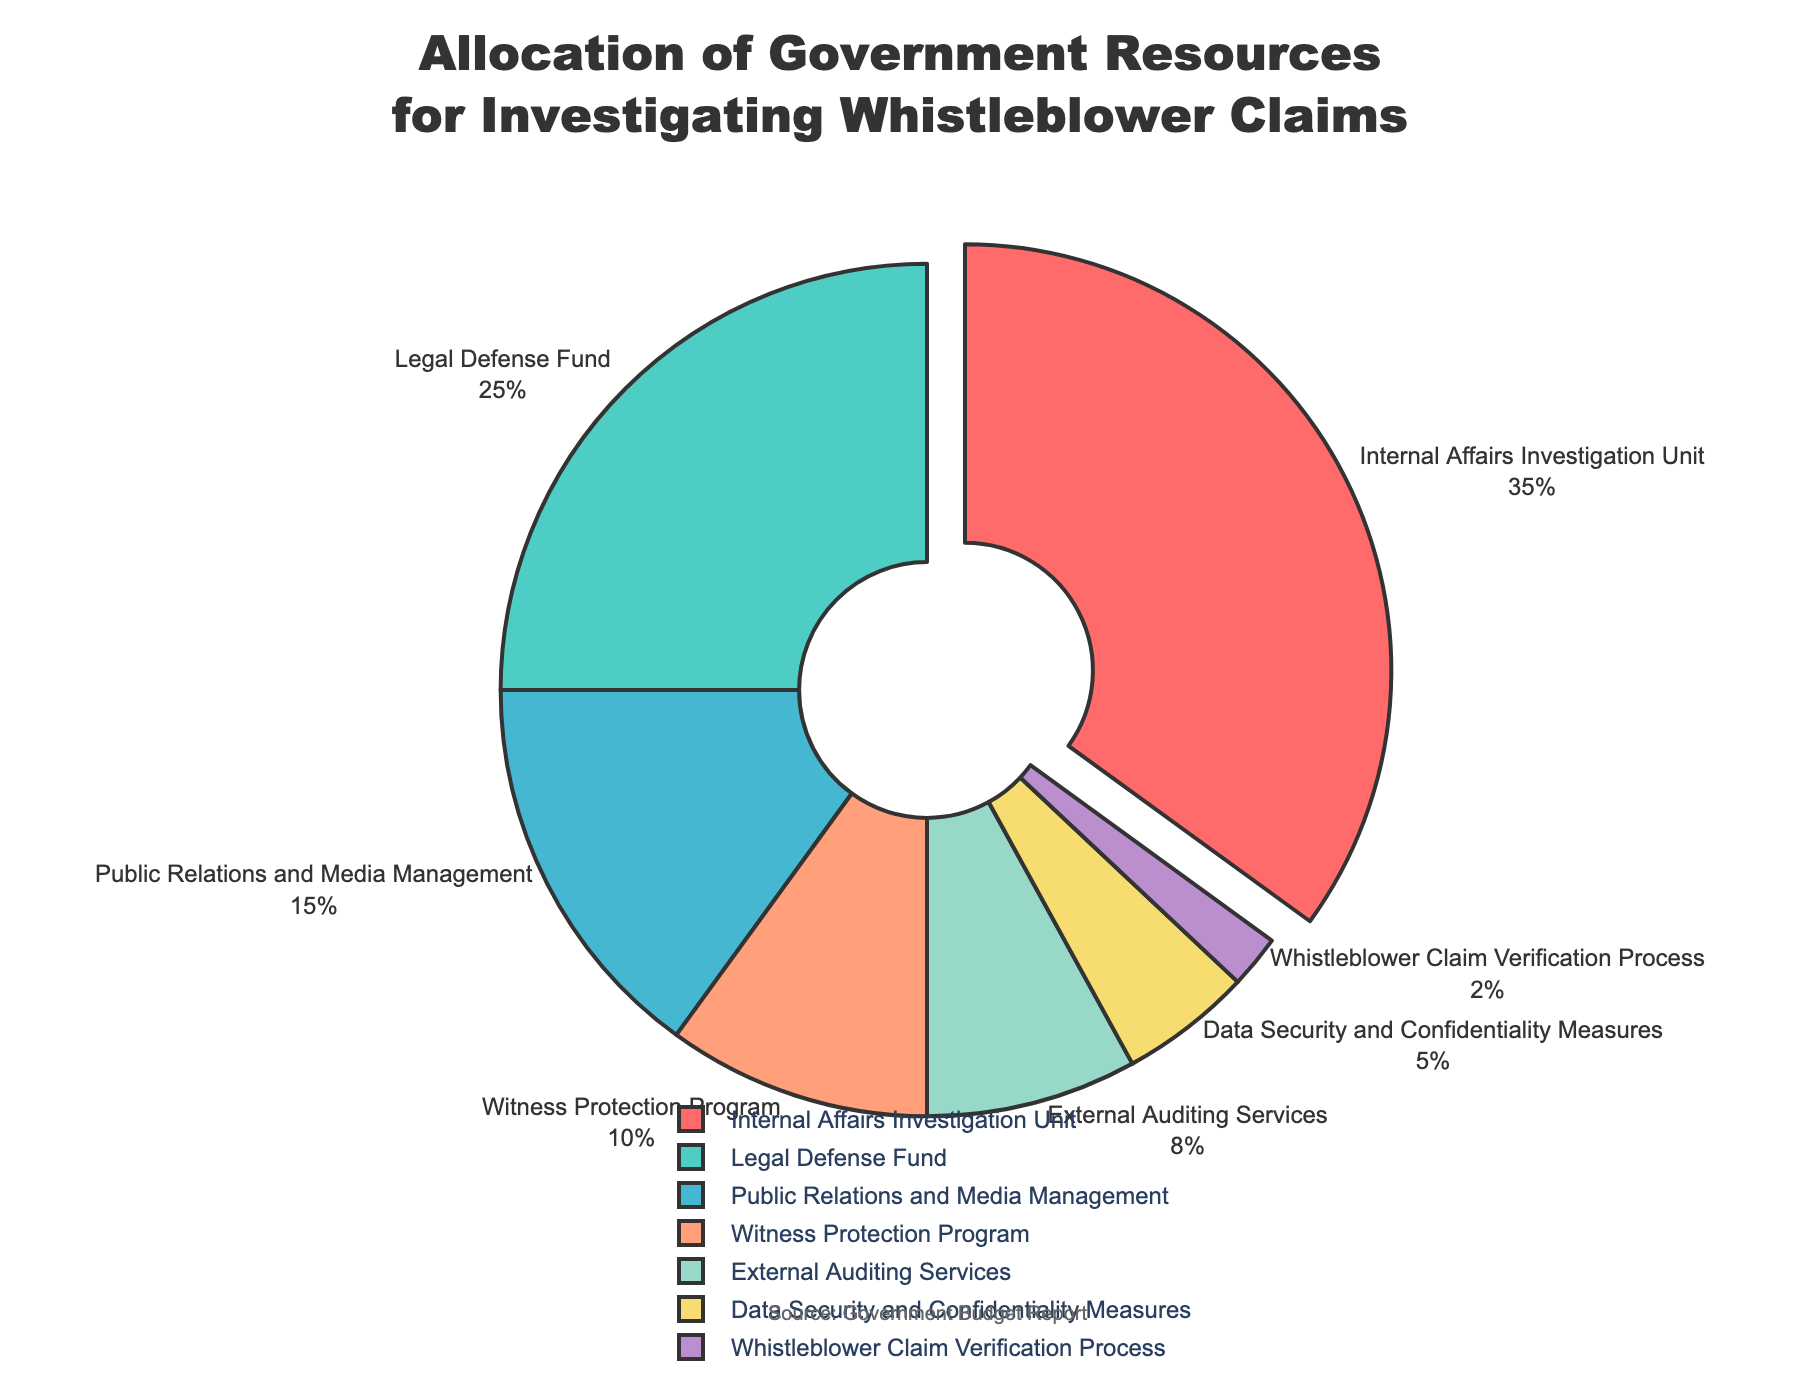How much greater is the budget allocation for the Internal Affairs Investigation Unit compared to the Witness Protection Program? The Internal Affairs Investigation Unit has a budget allocation of 35%, and the Witness Protection Program has a 10% allocation. The difference is calculated as 35% - 10% = 25%.
Answer: 25% Which department has the smallest budget allocation? By examining the pie chart, the department with the smallest slice is the Whistleblower Claim Verification Process, which has a budget allocation of 2%.
Answer: Whistleblower Claim Verification Process What is the combined budget allocation for Public Relations and Media Management, and External Auditing Services? The budget allocation for Public Relations and Media Management is 15%, and External Auditing Services is 8%. The total is calculated as 15% + 8% = 23%.
Answer: 23% Is the budget allocation for Legal Defense Fund more than or equal to the combined allocation for Data Security and Confidentiality Measures and Whistleblower Claim Verification Process? The budget allocation for the Legal Defense Fund is 25%. The combined allocation for Data Security and Confidentiality Measures (5%) and Whistleblower Claim Verification Process (2%) is 5% + 2% = 7%. Since 25% is greater than 7%, the answer is yes.
Answer: Yes Which department takes up 35% of the total budget allocation? By examining the chart, it is clear that the largest segment, representing 35% of the budget, belongs to the Internal Affairs Investigation Unit.
Answer: Internal Affairs Investigation Unit What is the total budget allocation for External Auditing Services and Data Security and Confidentiality Measures? The budget allocation for External Auditing Services is 8%, and for Data Security and Confidentiality Measures, it is 5%. The total is 8% + 5% = 13%.
Answer: 13% How much less budget allocation does the Witness Protection Program have compared to the total allocation for Public Relations and Media Management and External Auditing Services combined? The Witness Protection Program has a 10% allocation. The combined allocation for Public Relations and Media Management (15%) and External Auditing Services (8%) is 15% + 8% = 23%. The difference is 23% - 10% = 13%.
Answer: 13% What is the difference in budget allocation between the largest and the smallest categories in the pie chart? The largest category is the Internal Affairs Investigation Unit with 35%, and the smallest is the Whistleblower Claim Verification Process with 2%. The difference is 35% - 2% = 33%.
Answer: 33% Which department has a 25% allocation, and what color is its segment in the pie chart? The Legal Defense Fund has a 25% allocation. The pie chart shows this segment in a teal color.
Answer: Legal Defense Fund, teal 